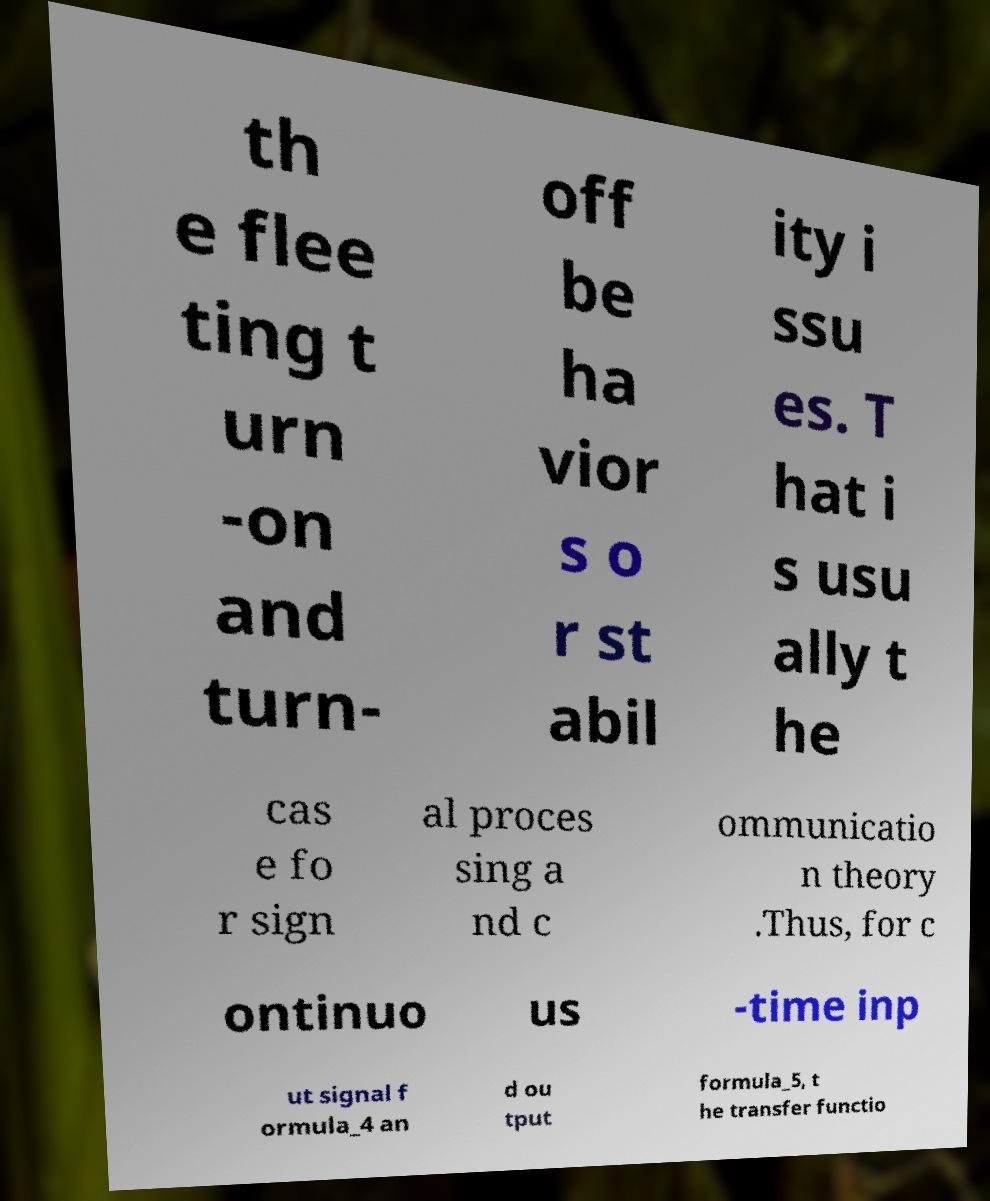Could you extract and type out the text from this image? th e flee ting t urn -on and turn- off be ha vior s o r st abil ity i ssu es. T hat i s usu ally t he cas e fo r sign al proces sing a nd c ommunicatio n theory .Thus, for c ontinuo us -time inp ut signal f ormula_4 an d ou tput formula_5, t he transfer functio 